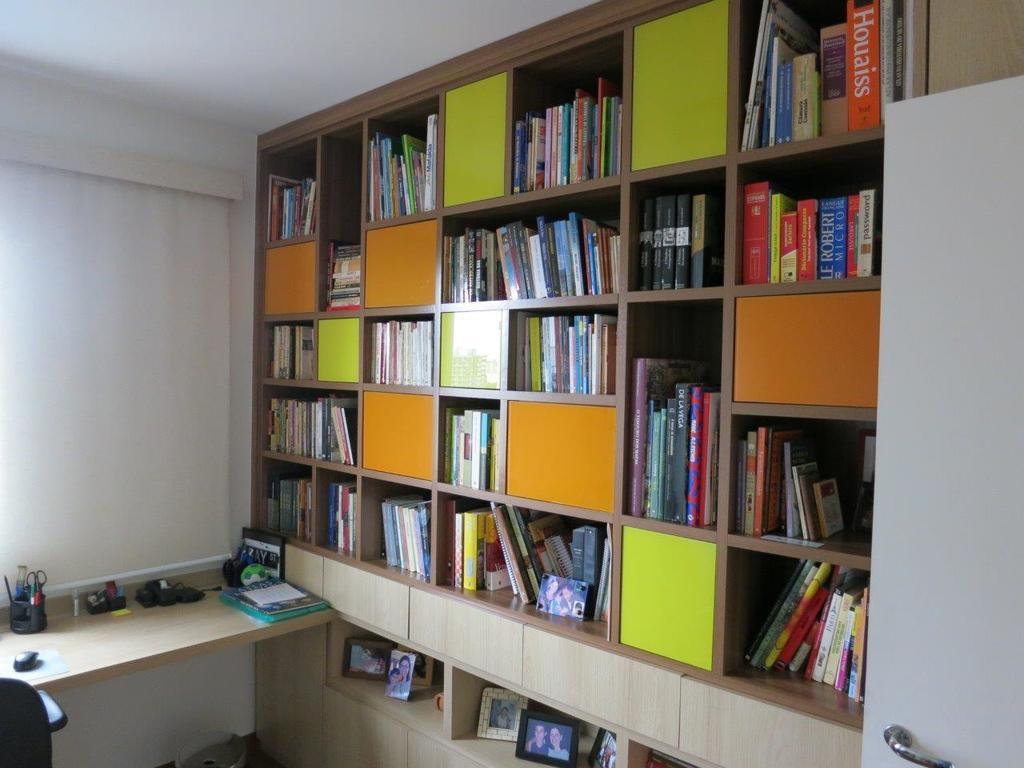<image>
Give a short and clear explanation of the subsequent image. A wooden shelf with several cubbies full of books including one about houlaiss. 